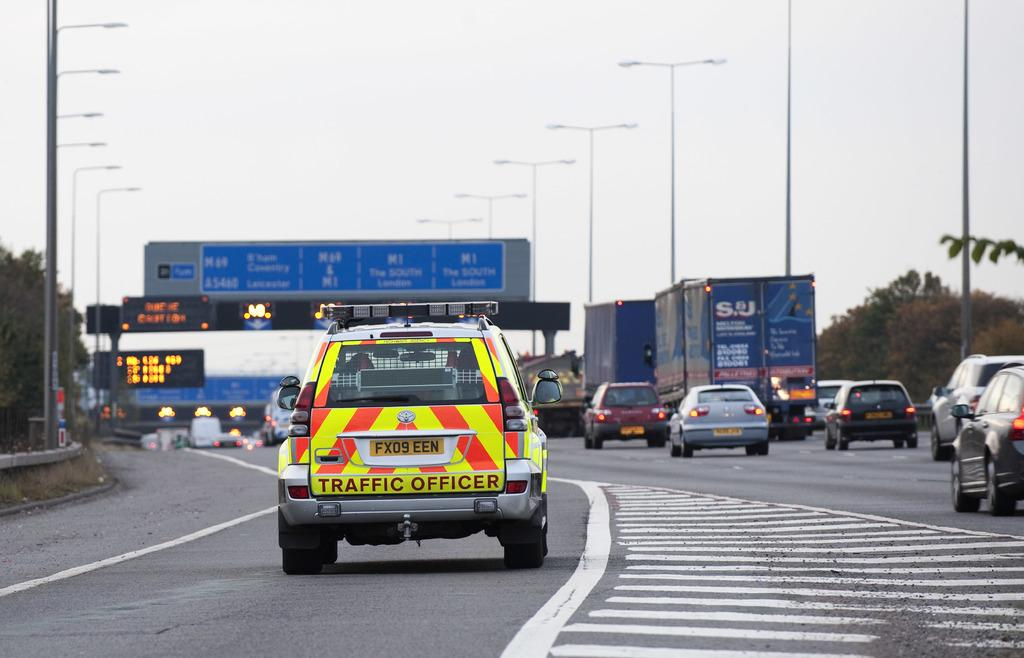What can be seen on the road in the image? There are cars and vehicles on the road in the image. What type of signs or information are present in the image? There are boards with text in the image. What provides illumination in the image? Pole lights are present in the image. What type of natural elements can be seen in the image? There are trees in the image. How would you describe the weather in the image? The sky is cloudy in the image. How many cows are grazing on the side of the road in the image? There are no cows present in the image; it features cars and vehicles on the road, boards with text, pole lights, trees, and a cloudy sky. What type of connection is being made between the cars in the image? There is no indication of a connection being made between the cars in the image; they are simply driving on the road. 